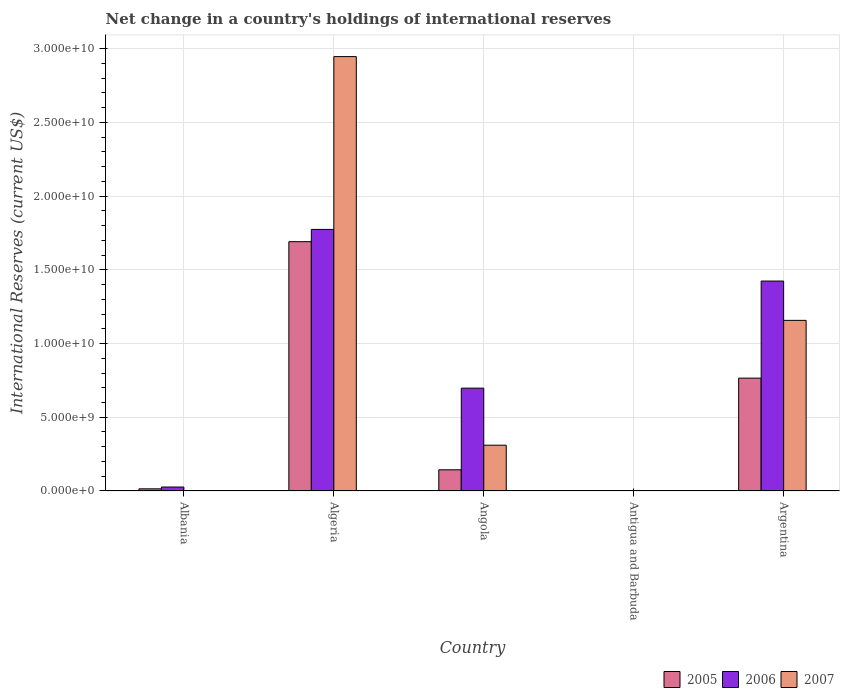How many different coloured bars are there?
Make the answer very short. 3. How many groups of bars are there?
Ensure brevity in your answer.  5. Are the number of bars per tick equal to the number of legend labels?
Your answer should be very brief. Yes. Are the number of bars on each tick of the X-axis equal?
Offer a terse response. Yes. How many bars are there on the 3rd tick from the left?
Give a very brief answer. 3. How many bars are there on the 5th tick from the right?
Make the answer very short. 3. What is the label of the 1st group of bars from the left?
Make the answer very short. Albania. What is the international reserves in 2007 in Argentina?
Ensure brevity in your answer.  1.16e+1. Across all countries, what is the maximum international reserves in 2007?
Ensure brevity in your answer.  2.95e+1. Across all countries, what is the minimum international reserves in 2007?
Your response must be concise. 3.68e+05. In which country was the international reserves in 2007 maximum?
Offer a terse response. Algeria. In which country was the international reserves in 2006 minimum?
Ensure brevity in your answer.  Antigua and Barbuda. What is the total international reserves in 2007 in the graph?
Provide a short and direct response. 4.41e+1. What is the difference between the international reserves in 2007 in Angola and that in Argentina?
Ensure brevity in your answer.  -8.46e+09. What is the difference between the international reserves in 2005 in Argentina and the international reserves in 2006 in Antigua and Barbuda?
Offer a very short reply. 7.64e+09. What is the average international reserves in 2006 per country?
Give a very brief answer. 7.85e+09. What is the difference between the international reserves of/in 2007 and international reserves of/in 2005 in Antigua and Barbuda?
Ensure brevity in your answer.  -6.87e+06. What is the ratio of the international reserves in 2005 in Algeria to that in Angola?
Offer a terse response. 11.76. Is the difference between the international reserves in 2007 in Albania and Algeria greater than the difference between the international reserves in 2005 in Albania and Algeria?
Keep it short and to the point. No. What is the difference between the highest and the second highest international reserves in 2005?
Offer a very short reply. 6.22e+09. What is the difference between the highest and the lowest international reserves in 2006?
Make the answer very short. 1.77e+1. In how many countries, is the international reserves in 2006 greater than the average international reserves in 2006 taken over all countries?
Offer a very short reply. 2. Is the sum of the international reserves in 2006 in Algeria and Angola greater than the maximum international reserves in 2007 across all countries?
Offer a terse response. No. What does the 2nd bar from the right in Antigua and Barbuda represents?
Keep it short and to the point. 2006. Are all the bars in the graph horizontal?
Offer a terse response. No. What is the difference between two consecutive major ticks on the Y-axis?
Ensure brevity in your answer.  5.00e+09. What is the title of the graph?
Your answer should be compact. Net change in a country's holdings of international reserves. Does "2013" appear as one of the legend labels in the graph?
Give a very brief answer. No. What is the label or title of the X-axis?
Give a very brief answer. Country. What is the label or title of the Y-axis?
Give a very brief answer. International Reserves (current US$). What is the International Reserves (current US$) in 2005 in Albania?
Provide a short and direct response. 1.48e+08. What is the International Reserves (current US$) of 2006 in Albania?
Keep it short and to the point. 2.69e+08. What is the International Reserves (current US$) of 2007 in Albania?
Make the answer very short. 1.97e+07. What is the International Reserves (current US$) of 2005 in Algeria?
Your response must be concise. 1.69e+1. What is the International Reserves (current US$) in 2006 in Algeria?
Your answer should be compact. 1.77e+1. What is the International Reserves (current US$) in 2007 in Algeria?
Give a very brief answer. 2.95e+1. What is the International Reserves (current US$) in 2005 in Angola?
Make the answer very short. 1.44e+09. What is the International Reserves (current US$) of 2006 in Angola?
Make the answer very short. 6.97e+09. What is the International Reserves (current US$) of 2007 in Angola?
Make the answer very short. 3.10e+09. What is the International Reserves (current US$) in 2005 in Antigua and Barbuda?
Make the answer very short. 7.24e+06. What is the International Reserves (current US$) of 2006 in Antigua and Barbuda?
Your answer should be compact. 1.54e+07. What is the International Reserves (current US$) of 2007 in Antigua and Barbuda?
Ensure brevity in your answer.  3.68e+05. What is the International Reserves (current US$) of 2005 in Argentina?
Your answer should be very brief. 7.65e+09. What is the International Reserves (current US$) in 2006 in Argentina?
Your response must be concise. 1.42e+1. What is the International Reserves (current US$) of 2007 in Argentina?
Keep it short and to the point. 1.16e+1. Across all countries, what is the maximum International Reserves (current US$) of 2005?
Provide a succinct answer. 1.69e+1. Across all countries, what is the maximum International Reserves (current US$) of 2006?
Provide a short and direct response. 1.77e+1. Across all countries, what is the maximum International Reserves (current US$) in 2007?
Your answer should be very brief. 2.95e+1. Across all countries, what is the minimum International Reserves (current US$) of 2005?
Offer a very short reply. 7.24e+06. Across all countries, what is the minimum International Reserves (current US$) of 2006?
Provide a short and direct response. 1.54e+07. Across all countries, what is the minimum International Reserves (current US$) in 2007?
Offer a very short reply. 3.68e+05. What is the total International Reserves (current US$) in 2005 in the graph?
Provide a short and direct response. 2.62e+1. What is the total International Reserves (current US$) in 2006 in the graph?
Provide a succinct answer. 3.92e+1. What is the total International Reserves (current US$) of 2007 in the graph?
Make the answer very short. 4.41e+1. What is the difference between the International Reserves (current US$) of 2005 in Albania and that in Algeria?
Keep it short and to the point. -1.68e+1. What is the difference between the International Reserves (current US$) in 2006 in Albania and that in Algeria?
Ensure brevity in your answer.  -1.75e+1. What is the difference between the International Reserves (current US$) in 2007 in Albania and that in Algeria?
Ensure brevity in your answer.  -2.94e+1. What is the difference between the International Reserves (current US$) of 2005 in Albania and that in Angola?
Offer a terse response. -1.29e+09. What is the difference between the International Reserves (current US$) of 2006 in Albania and that in Angola?
Provide a succinct answer. -6.70e+09. What is the difference between the International Reserves (current US$) of 2007 in Albania and that in Angola?
Your response must be concise. -3.09e+09. What is the difference between the International Reserves (current US$) of 2005 in Albania and that in Antigua and Barbuda?
Provide a succinct answer. 1.41e+08. What is the difference between the International Reserves (current US$) in 2006 in Albania and that in Antigua and Barbuda?
Provide a succinct answer. 2.54e+08. What is the difference between the International Reserves (current US$) in 2007 in Albania and that in Antigua and Barbuda?
Your answer should be compact. 1.93e+07. What is the difference between the International Reserves (current US$) in 2005 in Albania and that in Argentina?
Your answer should be very brief. -7.51e+09. What is the difference between the International Reserves (current US$) of 2006 in Albania and that in Argentina?
Give a very brief answer. -1.40e+1. What is the difference between the International Reserves (current US$) of 2007 in Albania and that in Argentina?
Give a very brief answer. -1.15e+1. What is the difference between the International Reserves (current US$) in 2005 in Algeria and that in Angola?
Give a very brief answer. 1.55e+1. What is the difference between the International Reserves (current US$) of 2006 in Algeria and that in Angola?
Your answer should be very brief. 1.08e+1. What is the difference between the International Reserves (current US$) of 2007 in Algeria and that in Angola?
Your answer should be compact. 2.63e+1. What is the difference between the International Reserves (current US$) in 2005 in Algeria and that in Antigua and Barbuda?
Your answer should be very brief. 1.69e+1. What is the difference between the International Reserves (current US$) in 2006 in Algeria and that in Antigua and Barbuda?
Ensure brevity in your answer.  1.77e+1. What is the difference between the International Reserves (current US$) in 2007 in Algeria and that in Antigua and Barbuda?
Keep it short and to the point. 2.95e+1. What is the difference between the International Reserves (current US$) in 2005 in Algeria and that in Argentina?
Keep it short and to the point. 9.25e+09. What is the difference between the International Reserves (current US$) of 2006 in Algeria and that in Argentina?
Your response must be concise. 3.50e+09. What is the difference between the International Reserves (current US$) in 2007 in Algeria and that in Argentina?
Make the answer very short. 1.79e+1. What is the difference between the International Reserves (current US$) of 2005 in Angola and that in Antigua and Barbuda?
Your answer should be compact. 1.43e+09. What is the difference between the International Reserves (current US$) of 2006 in Angola and that in Antigua and Barbuda?
Provide a succinct answer. 6.96e+09. What is the difference between the International Reserves (current US$) of 2007 in Angola and that in Antigua and Barbuda?
Make the answer very short. 3.10e+09. What is the difference between the International Reserves (current US$) of 2005 in Angola and that in Argentina?
Keep it short and to the point. -6.22e+09. What is the difference between the International Reserves (current US$) in 2006 in Angola and that in Argentina?
Offer a very short reply. -7.26e+09. What is the difference between the International Reserves (current US$) of 2007 in Angola and that in Argentina?
Your answer should be compact. -8.46e+09. What is the difference between the International Reserves (current US$) in 2005 in Antigua and Barbuda and that in Argentina?
Offer a terse response. -7.65e+09. What is the difference between the International Reserves (current US$) in 2006 in Antigua and Barbuda and that in Argentina?
Offer a very short reply. -1.42e+1. What is the difference between the International Reserves (current US$) of 2007 in Antigua and Barbuda and that in Argentina?
Provide a short and direct response. -1.16e+1. What is the difference between the International Reserves (current US$) in 2005 in Albania and the International Reserves (current US$) in 2006 in Algeria?
Keep it short and to the point. -1.76e+1. What is the difference between the International Reserves (current US$) in 2005 in Albania and the International Reserves (current US$) in 2007 in Algeria?
Make the answer very short. -2.93e+1. What is the difference between the International Reserves (current US$) of 2006 in Albania and the International Reserves (current US$) of 2007 in Algeria?
Keep it short and to the point. -2.92e+1. What is the difference between the International Reserves (current US$) of 2005 in Albania and the International Reserves (current US$) of 2006 in Angola?
Your response must be concise. -6.83e+09. What is the difference between the International Reserves (current US$) of 2005 in Albania and the International Reserves (current US$) of 2007 in Angola?
Offer a very short reply. -2.96e+09. What is the difference between the International Reserves (current US$) of 2006 in Albania and the International Reserves (current US$) of 2007 in Angola?
Give a very brief answer. -2.84e+09. What is the difference between the International Reserves (current US$) of 2005 in Albania and the International Reserves (current US$) of 2006 in Antigua and Barbuda?
Your answer should be very brief. 1.32e+08. What is the difference between the International Reserves (current US$) in 2005 in Albania and the International Reserves (current US$) in 2007 in Antigua and Barbuda?
Provide a succinct answer. 1.47e+08. What is the difference between the International Reserves (current US$) in 2006 in Albania and the International Reserves (current US$) in 2007 in Antigua and Barbuda?
Your response must be concise. 2.69e+08. What is the difference between the International Reserves (current US$) of 2005 in Albania and the International Reserves (current US$) of 2006 in Argentina?
Give a very brief answer. -1.41e+1. What is the difference between the International Reserves (current US$) of 2005 in Albania and the International Reserves (current US$) of 2007 in Argentina?
Your answer should be very brief. -1.14e+1. What is the difference between the International Reserves (current US$) of 2006 in Albania and the International Reserves (current US$) of 2007 in Argentina?
Ensure brevity in your answer.  -1.13e+1. What is the difference between the International Reserves (current US$) in 2005 in Algeria and the International Reserves (current US$) in 2006 in Angola?
Make the answer very short. 9.93e+09. What is the difference between the International Reserves (current US$) of 2005 in Algeria and the International Reserves (current US$) of 2007 in Angola?
Keep it short and to the point. 1.38e+1. What is the difference between the International Reserves (current US$) in 2006 in Algeria and the International Reserves (current US$) in 2007 in Angola?
Give a very brief answer. 1.46e+1. What is the difference between the International Reserves (current US$) in 2005 in Algeria and the International Reserves (current US$) in 2006 in Antigua and Barbuda?
Give a very brief answer. 1.69e+1. What is the difference between the International Reserves (current US$) in 2005 in Algeria and the International Reserves (current US$) in 2007 in Antigua and Barbuda?
Keep it short and to the point. 1.69e+1. What is the difference between the International Reserves (current US$) of 2006 in Algeria and the International Reserves (current US$) of 2007 in Antigua and Barbuda?
Make the answer very short. 1.77e+1. What is the difference between the International Reserves (current US$) in 2005 in Algeria and the International Reserves (current US$) in 2006 in Argentina?
Offer a terse response. 2.67e+09. What is the difference between the International Reserves (current US$) of 2005 in Algeria and the International Reserves (current US$) of 2007 in Argentina?
Your answer should be compact. 5.33e+09. What is the difference between the International Reserves (current US$) in 2006 in Algeria and the International Reserves (current US$) in 2007 in Argentina?
Provide a succinct answer. 6.17e+09. What is the difference between the International Reserves (current US$) in 2005 in Angola and the International Reserves (current US$) in 2006 in Antigua and Barbuda?
Provide a succinct answer. 1.42e+09. What is the difference between the International Reserves (current US$) of 2005 in Angola and the International Reserves (current US$) of 2007 in Antigua and Barbuda?
Your answer should be very brief. 1.44e+09. What is the difference between the International Reserves (current US$) in 2006 in Angola and the International Reserves (current US$) in 2007 in Antigua and Barbuda?
Give a very brief answer. 6.97e+09. What is the difference between the International Reserves (current US$) in 2005 in Angola and the International Reserves (current US$) in 2006 in Argentina?
Your answer should be compact. -1.28e+1. What is the difference between the International Reserves (current US$) of 2005 in Angola and the International Reserves (current US$) of 2007 in Argentina?
Give a very brief answer. -1.01e+1. What is the difference between the International Reserves (current US$) in 2006 in Angola and the International Reserves (current US$) in 2007 in Argentina?
Provide a short and direct response. -4.60e+09. What is the difference between the International Reserves (current US$) of 2005 in Antigua and Barbuda and the International Reserves (current US$) of 2006 in Argentina?
Give a very brief answer. -1.42e+1. What is the difference between the International Reserves (current US$) in 2005 in Antigua and Barbuda and the International Reserves (current US$) in 2007 in Argentina?
Offer a very short reply. -1.16e+1. What is the difference between the International Reserves (current US$) of 2006 in Antigua and Barbuda and the International Reserves (current US$) of 2007 in Argentina?
Your response must be concise. -1.16e+1. What is the average International Reserves (current US$) in 2005 per country?
Provide a short and direct response. 5.23e+09. What is the average International Reserves (current US$) in 2006 per country?
Your response must be concise. 7.85e+09. What is the average International Reserves (current US$) in 2007 per country?
Give a very brief answer. 8.83e+09. What is the difference between the International Reserves (current US$) of 2005 and International Reserves (current US$) of 2006 in Albania?
Make the answer very short. -1.21e+08. What is the difference between the International Reserves (current US$) of 2005 and International Reserves (current US$) of 2007 in Albania?
Offer a very short reply. 1.28e+08. What is the difference between the International Reserves (current US$) of 2006 and International Reserves (current US$) of 2007 in Albania?
Provide a succinct answer. 2.50e+08. What is the difference between the International Reserves (current US$) in 2005 and International Reserves (current US$) in 2006 in Algeria?
Your answer should be very brief. -8.32e+08. What is the difference between the International Reserves (current US$) in 2005 and International Reserves (current US$) in 2007 in Algeria?
Your answer should be very brief. -1.25e+1. What is the difference between the International Reserves (current US$) in 2006 and International Reserves (current US$) in 2007 in Algeria?
Ensure brevity in your answer.  -1.17e+1. What is the difference between the International Reserves (current US$) in 2005 and International Reserves (current US$) in 2006 in Angola?
Ensure brevity in your answer.  -5.54e+09. What is the difference between the International Reserves (current US$) of 2005 and International Reserves (current US$) of 2007 in Angola?
Provide a succinct answer. -1.67e+09. What is the difference between the International Reserves (current US$) in 2006 and International Reserves (current US$) in 2007 in Angola?
Your answer should be very brief. 3.87e+09. What is the difference between the International Reserves (current US$) in 2005 and International Reserves (current US$) in 2006 in Antigua and Barbuda?
Provide a short and direct response. -8.13e+06. What is the difference between the International Reserves (current US$) in 2005 and International Reserves (current US$) in 2007 in Antigua and Barbuda?
Your answer should be very brief. 6.87e+06. What is the difference between the International Reserves (current US$) of 2006 and International Reserves (current US$) of 2007 in Antigua and Barbuda?
Offer a terse response. 1.50e+07. What is the difference between the International Reserves (current US$) in 2005 and International Reserves (current US$) in 2006 in Argentina?
Provide a succinct answer. -6.58e+09. What is the difference between the International Reserves (current US$) in 2005 and International Reserves (current US$) in 2007 in Argentina?
Give a very brief answer. -3.92e+09. What is the difference between the International Reserves (current US$) in 2006 and International Reserves (current US$) in 2007 in Argentina?
Offer a terse response. 2.67e+09. What is the ratio of the International Reserves (current US$) of 2005 in Albania to that in Algeria?
Offer a very short reply. 0.01. What is the ratio of the International Reserves (current US$) of 2006 in Albania to that in Algeria?
Provide a succinct answer. 0.02. What is the ratio of the International Reserves (current US$) in 2007 in Albania to that in Algeria?
Make the answer very short. 0. What is the ratio of the International Reserves (current US$) of 2005 in Albania to that in Angola?
Keep it short and to the point. 0.1. What is the ratio of the International Reserves (current US$) of 2006 in Albania to that in Angola?
Make the answer very short. 0.04. What is the ratio of the International Reserves (current US$) of 2007 in Albania to that in Angola?
Your answer should be very brief. 0.01. What is the ratio of the International Reserves (current US$) of 2005 in Albania to that in Antigua and Barbuda?
Your answer should be compact. 20.42. What is the ratio of the International Reserves (current US$) of 2006 in Albania to that in Antigua and Barbuda?
Provide a succinct answer. 17.53. What is the ratio of the International Reserves (current US$) in 2007 in Albania to that in Antigua and Barbuda?
Your answer should be compact. 53.37. What is the ratio of the International Reserves (current US$) of 2005 in Albania to that in Argentina?
Provide a succinct answer. 0.02. What is the ratio of the International Reserves (current US$) of 2006 in Albania to that in Argentina?
Offer a very short reply. 0.02. What is the ratio of the International Reserves (current US$) in 2007 in Albania to that in Argentina?
Provide a succinct answer. 0. What is the ratio of the International Reserves (current US$) of 2005 in Algeria to that in Angola?
Provide a short and direct response. 11.76. What is the ratio of the International Reserves (current US$) in 2006 in Algeria to that in Angola?
Offer a terse response. 2.54. What is the ratio of the International Reserves (current US$) of 2007 in Algeria to that in Angola?
Make the answer very short. 9.49. What is the ratio of the International Reserves (current US$) of 2005 in Algeria to that in Antigua and Barbuda?
Your answer should be very brief. 2336.07. What is the ratio of the International Reserves (current US$) of 2006 in Algeria to that in Antigua and Barbuda?
Keep it short and to the point. 1154.57. What is the ratio of the International Reserves (current US$) in 2007 in Algeria to that in Antigua and Barbuda?
Provide a short and direct response. 7.99e+04. What is the ratio of the International Reserves (current US$) in 2005 in Algeria to that in Argentina?
Offer a very short reply. 2.21. What is the ratio of the International Reserves (current US$) of 2006 in Algeria to that in Argentina?
Your response must be concise. 1.25. What is the ratio of the International Reserves (current US$) of 2007 in Algeria to that in Argentina?
Make the answer very short. 2.55. What is the ratio of the International Reserves (current US$) of 2005 in Angola to that in Antigua and Barbuda?
Your answer should be compact. 198.69. What is the ratio of the International Reserves (current US$) of 2006 in Angola to that in Antigua and Barbuda?
Make the answer very short. 453.95. What is the ratio of the International Reserves (current US$) in 2007 in Angola to that in Antigua and Barbuda?
Provide a short and direct response. 8426. What is the ratio of the International Reserves (current US$) of 2005 in Angola to that in Argentina?
Provide a succinct answer. 0.19. What is the ratio of the International Reserves (current US$) of 2006 in Angola to that in Argentina?
Offer a terse response. 0.49. What is the ratio of the International Reserves (current US$) in 2007 in Angola to that in Argentina?
Your answer should be very brief. 0.27. What is the ratio of the International Reserves (current US$) in 2005 in Antigua and Barbuda to that in Argentina?
Offer a terse response. 0. What is the ratio of the International Reserves (current US$) in 2006 in Antigua and Barbuda to that in Argentina?
Keep it short and to the point. 0. What is the ratio of the International Reserves (current US$) in 2007 in Antigua and Barbuda to that in Argentina?
Provide a succinct answer. 0. What is the difference between the highest and the second highest International Reserves (current US$) of 2005?
Your answer should be compact. 9.25e+09. What is the difference between the highest and the second highest International Reserves (current US$) in 2006?
Offer a very short reply. 3.50e+09. What is the difference between the highest and the second highest International Reserves (current US$) of 2007?
Your answer should be compact. 1.79e+1. What is the difference between the highest and the lowest International Reserves (current US$) of 2005?
Your answer should be compact. 1.69e+1. What is the difference between the highest and the lowest International Reserves (current US$) of 2006?
Give a very brief answer. 1.77e+1. What is the difference between the highest and the lowest International Reserves (current US$) of 2007?
Provide a short and direct response. 2.95e+1. 